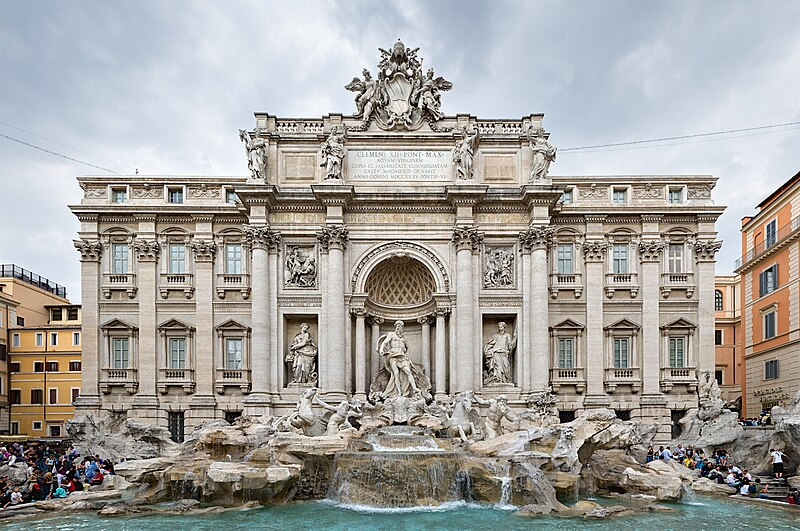Explain the visual content of the image in great detail. This image captures the magnificence of the Trevi Fountain, one of Rome's most iconic landmarks. Made from white marble, this masterpiece of Baroque art showcases detailed sculptures that depict mythological figures, with a central statue of Oceanus flanked by Tritons guiding sea horses. The bright blue water beautifully cascades into the large basin below. The fountain is shown in a full view, emphasizing its grandiosity against the densely gathered crowd, illustrating its status as a major tourist attraction. The surrounding architecture, with buildings painted in warm tones of yellow and orange, juxtaposes elegantly against an overcast sky, creating a balanced and picturesque setting. This image not only highlights the artistic and architectural splendor of the Trevi Fountain but also places it within the lively and historic urban context of Rome, epitomizing the city's rich cultural heritage. 